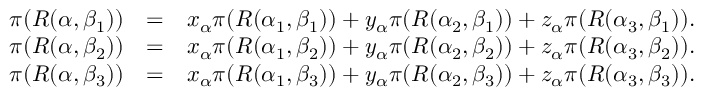<formula> <loc_0><loc_0><loc_500><loc_500>\begin{array} { r l r } { \pi ( R ( \alpha , \beta _ { 1 } ) ) } & { = } & { x _ { \alpha } \pi ( R ( \alpha _ { 1 } , \beta _ { 1 } ) ) + y _ { \alpha } \pi ( R ( \alpha _ { 2 } , \beta _ { 1 } ) ) + z _ { \alpha } \pi ( R ( \alpha _ { 3 } , \beta _ { 1 } ) ) . } \\ { \pi ( R ( \alpha , \beta _ { 2 } ) ) } & { = } & { x _ { \alpha } \pi ( R ( \alpha _ { 1 } , \beta _ { 2 } ) ) + y _ { \alpha } \pi ( R ( \alpha _ { 2 } , \beta _ { 2 } ) ) + z _ { \alpha } \pi ( R ( \alpha _ { 3 } , \beta _ { 2 } ) ) . } \\ { \pi ( R ( \alpha , \beta _ { 3 } ) ) } & { = } & { x _ { \alpha } \pi ( R ( \alpha _ { 1 } , \beta _ { 3 } ) ) + y _ { \alpha } \pi ( R ( \alpha _ { 2 } , \beta _ { 3 } ) ) + z _ { \alpha } \pi ( R ( \alpha _ { 3 } , \beta _ { 3 } ) ) . } \end{array}</formula> 